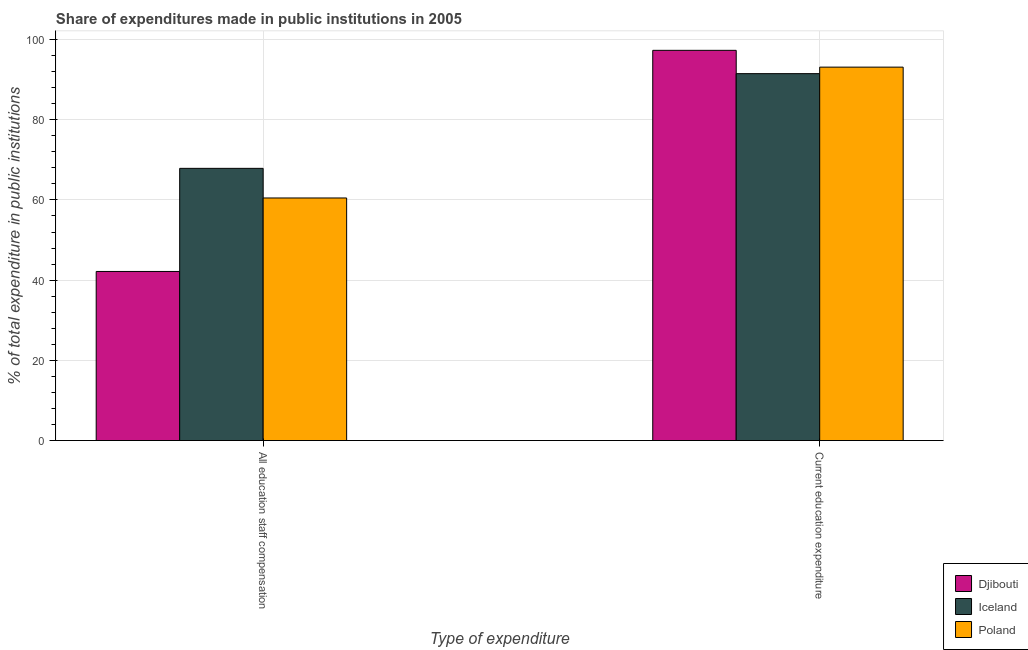How many groups of bars are there?
Offer a very short reply. 2. What is the label of the 2nd group of bars from the left?
Your answer should be compact. Current education expenditure. What is the expenditure in education in Poland?
Keep it short and to the point. 93.12. Across all countries, what is the maximum expenditure in education?
Your response must be concise. 97.31. Across all countries, what is the minimum expenditure in education?
Your answer should be very brief. 91.49. In which country was the expenditure in education maximum?
Keep it short and to the point. Djibouti. In which country was the expenditure in education minimum?
Provide a short and direct response. Iceland. What is the total expenditure in education in the graph?
Offer a terse response. 281.92. What is the difference between the expenditure in education in Poland and that in Djibouti?
Offer a very short reply. -4.19. What is the difference between the expenditure in education in Iceland and the expenditure in staff compensation in Poland?
Your answer should be very brief. 31. What is the average expenditure in staff compensation per country?
Provide a succinct answer. 56.85. What is the difference between the expenditure in staff compensation and expenditure in education in Poland?
Provide a succinct answer. -32.63. What is the ratio of the expenditure in education in Iceland to that in Poland?
Your answer should be very brief. 0.98. What does the 3rd bar from the right in All education staff compensation represents?
Make the answer very short. Djibouti. How many countries are there in the graph?
Your answer should be compact. 3. What is the difference between two consecutive major ticks on the Y-axis?
Provide a succinct answer. 20. Does the graph contain grids?
Offer a very short reply. Yes. Where does the legend appear in the graph?
Your answer should be compact. Bottom right. What is the title of the graph?
Your response must be concise. Share of expenditures made in public institutions in 2005. What is the label or title of the X-axis?
Your answer should be very brief. Type of expenditure. What is the label or title of the Y-axis?
Offer a very short reply. % of total expenditure in public institutions. What is the % of total expenditure in public institutions in Djibouti in All education staff compensation?
Offer a very short reply. 42.17. What is the % of total expenditure in public institutions of Iceland in All education staff compensation?
Your response must be concise. 67.88. What is the % of total expenditure in public institutions of Poland in All education staff compensation?
Your answer should be compact. 60.49. What is the % of total expenditure in public institutions of Djibouti in Current education expenditure?
Ensure brevity in your answer.  97.31. What is the % of total expenditure in public institutions of Iceland in Current education expenditure?
Provide a short and direct response. 91.49. What is the % of total expenditure in public institutions of Poland in Current education expenditure?
Provide a short and direct response. 93.12. Across all Type of expenditure, what is the maximum % of total expenditure in public institutions in Djibouti?
Offer a terse response. 97.31. Across all Type of expenditure, what is the maximum % of total expenditure in public institutions of Iceland?
Provide a succinct answer. 91.49. Across all Type of expenditure, what is the maximum % of total expenditure in public institutions of Poland?
Offer a terse response. 93.12. Across all Type of expenditure, what is the minimum % of total expenditure in public institutions of Djibouti?
Provide a succinct answer. 42.17. Across all Type of expenditure, what is the minimum % of total expenditure in public institutions of Iceland?
Make the answer very short. 67.88. Across all Type of expenditure, what is the minimum % of total expenditure in public institutions of Poland?
Your response must be concise. 60.49. What is the total % of total expenditure in public institutions of Djibouti in the graph?
Your response must be concise. 139.48. What is the total % of total expenditure in public institutions in Iceland in the graph?
Provide a short and direct response. 159.37. What is the total % of total expenditure in public institutions in Poland in the graph?
Give a very brief answer. 153.61. What is the difference between the % of total expenditure in public institutions of Djibouti in All education staff compensation and that in Current education expenditure?
Your response must be concise. -55.14. What is the difference between the % of total expenditure in public institutions of Iceland in All education staff compensation and that in Current education expenditure?
Provide a short and direct response. -23.62. What is the difference between the % of total expenditure in public institutions of Poland in All education staff compensation and that in Current education expenditure?
Give a very brief answer. -32.63. What is the difference between the % of total expenditure in public institutions of Djibouti in All education staff compensation and the % of total expenditure in public institutions of Iceland in Current education expenditure?
Keep it short and to the point. -49.32. What is the difference between the % of total expenditure in public institutions in Djibouti in All education staff compensation and the % of total expenditure in public institutions in Poland in Current education expenditure?
Make the answer very short. -50.95. What is the difference between the % of total expenditure in public institutions in Iceland in All education staff compensation and the % of total expenditure in public institutions in Poland in Current education expenditure?
Your answer should be compact. -25.24. What is the average % of total expenditure in public institutions of Djibouti per Type of expenditure?
Offer a very short reply. 69.74. What is the average % of total expenditure in public institutions in Iceland per Type of expenditure?
Keep it short and to the point. 79.69. What is the average % of total expenditure in public institutions of Poland per Type of expenditure?
Offer a terse response. 76.81. What is the difference between the % of total expenditure in public institutions in Djibouti and % of total expenditure in public institutions in Iceland in All education staff compensation?
Ensure brevity in your answer.  -25.71. What is the difference between the % of total expenditure in public institutions of Djibouti and % of total expenditure in public institutions of Poland in All education staff compensation?
Make the answer very short. -18.32. What is the difference between the % of total expenditure in public institutions in Iceland and % of total expenditure in public institutions in Poland in All education staff compensation?
Make the answer very short. 7.39. What is the difference between the % of total expenditure in public institutions in Djibouti and % of total expenditure in public institutions in Iceland in Current education expenditure?
Provide a succinct answer. 5.81. What is the difference between the % of total expenditure in public institutions of Djibouti and % of total expenditure in public institutions of Poland in Current education expenditure?
Your answer should be compact. 4.19. What is the difference between the % of total expenditure in public institutions of Iceland and % of total expenditure in public institutions of Poland in Current education expenditure?
Give a very brief answer. -1.63. What is the ratio of the % of total expenditure in public institutions in Djibouti in All education staff compensation to that in Current education expenditure?
Provide a short and direct response. 0.43. What is the ratio of the % of total expenditure in public institutions in Iceland in All education staff compensation to that in Current education expenditure?
Your answer should be very brief. 0.74. What is the ratio of the % of total expenditure in public institutions in Poland in All education staff compensation to that in Current education expenditure?
Offer a terse response. 0.65. What is the difference between the highest and the second highest % of total expenditure in public institutions of Djibouti?
Make the answer very short. 55.14. What is the difference between the highest and the second highest % of total expenditure in public institutions of Iceland?
Provide a short and direct response. 23.62. What is the difference between the highest and the second highest % of total expenditure in public institutions in Poland?
Keep it short and to the point. 32.63. What is the difference between the highest and the lowest % of total expenditure in public institutions of Djibouti?
Offer a very short reply. 55.14. What is the difference between the highest and the lowest % of total expenditure in public institutions in Iceland?
Make the answer very short. 23.62. What is the difference between the highest and the lowest % of total expenditure in public institutions of Poland?
Offer a very short reply. 32.63. 